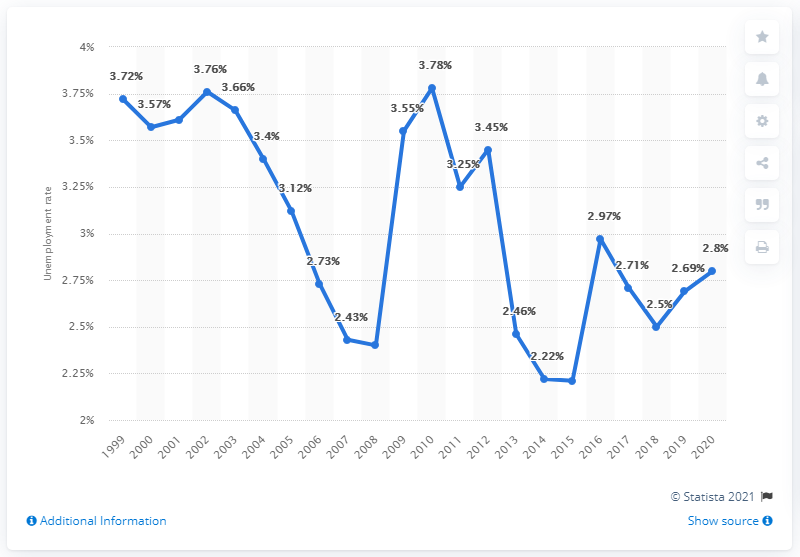Specify some key components in this picture. In 2020, the unemployment rate in Trinidad and Tobago was 2.8%. 